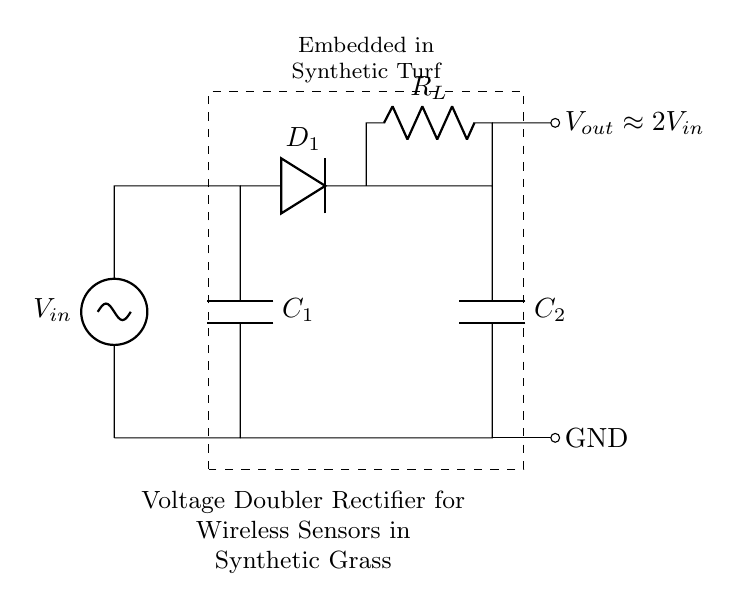What is the type of the circuit shown? The circuit is a voltage doubler rectifier, as indicated by the configuration of diodes and capacitors that is designed to double the input voltage.
Answer: voltage doubler rectifier How many capacitors are present in the circuit? There are two capacitors labeled C1 and C2 in the circuit diagram.
Answer: 2 What is the purpose of the component labeled R_L? R_L represents the load resistor, which dissipates the output voltage from the circuit, allowing the powered sensors to function.
Answer: load resistor What approximate output voltage does this circuit provide? The output voltage is approximately double the input voltage, as stated in the diagram where it notes V_out is approximately 2V_in.
Answer: 2V_in Which components are responsible for rectification in the circuit? The diodes D1 are responsible for rectification, allowing current to flow in only one direction, thereby converting AC to DC.
Answer: D1 What does the dashed rectangle signify in the diagram? The dashed rectangle indicates the area of the embedded system within the synthetic turf, encapsulating the components and their function in that environment.
Answer: embedded system area What is the function of the capacitor labeled C2? The capacitor C2 stores the rectified charge and helps maintain a smoother DC output voltage for the load connected to the circuit.
Answer: store charge 